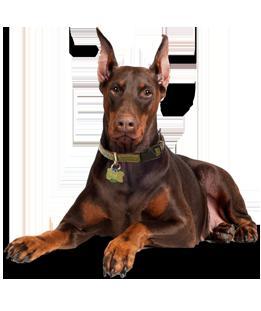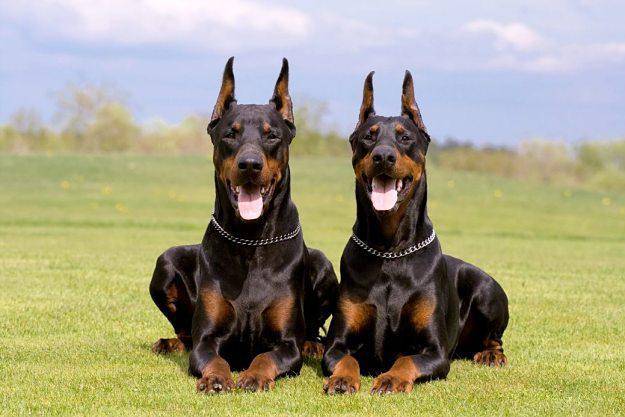The first image is the image on the left, the second image is the image on the right. Assess this claim about the two images: "A dog is looking towards the right in the right image.". Correct or not? Answer yes or no. No. The first image is the image on the left, the second image is the image on the right. Analyze the images presented: Is the assertion "One of the dogs has uncropped ears." valid? Answer yes or no. No. 